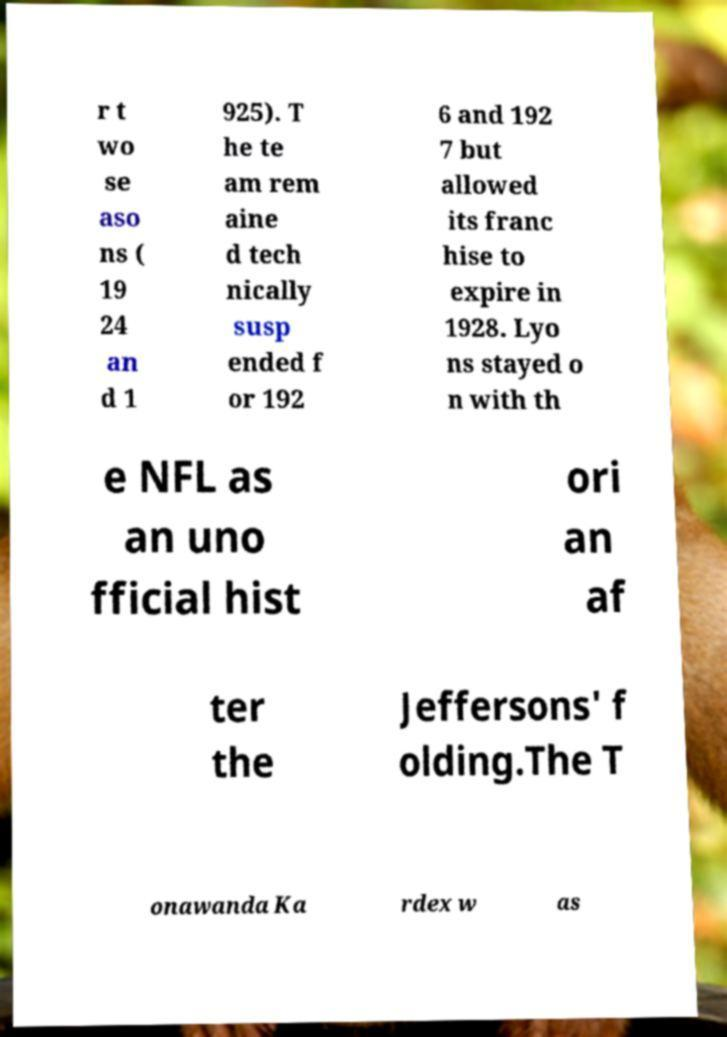Could you extract and type out the text from this image? r t wo se aso ns ( 19 24 an d 1 925). T he te am rem aine d tech nically susp ended f or 192 6 and 192 7 but allowed its franc hise to expire in 1928. Lyo ns stayed o n with th e NFL as an uno fficial hist ori an af ter the Jeffersons' f olding.The T onawanda Ka rdex w as 